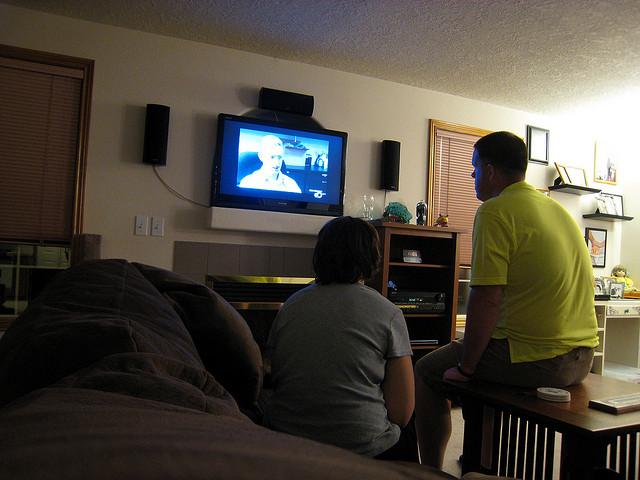Is this a barber shop?
Short answer required. No. What is cast?
Give a very brief answer. News. Is the tv on?
Answer briefly. Yes. How many light switches are there?
Write a very short answer. 2. Is all the color scheme in the room of neutral tones?
Answer briefly. Yes. 